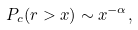<formula> <loc_0><loc_0><loc_500><loc_500>P _ { c } ( r > x ) \sim x ^ { - \alpha } ,</formula> 